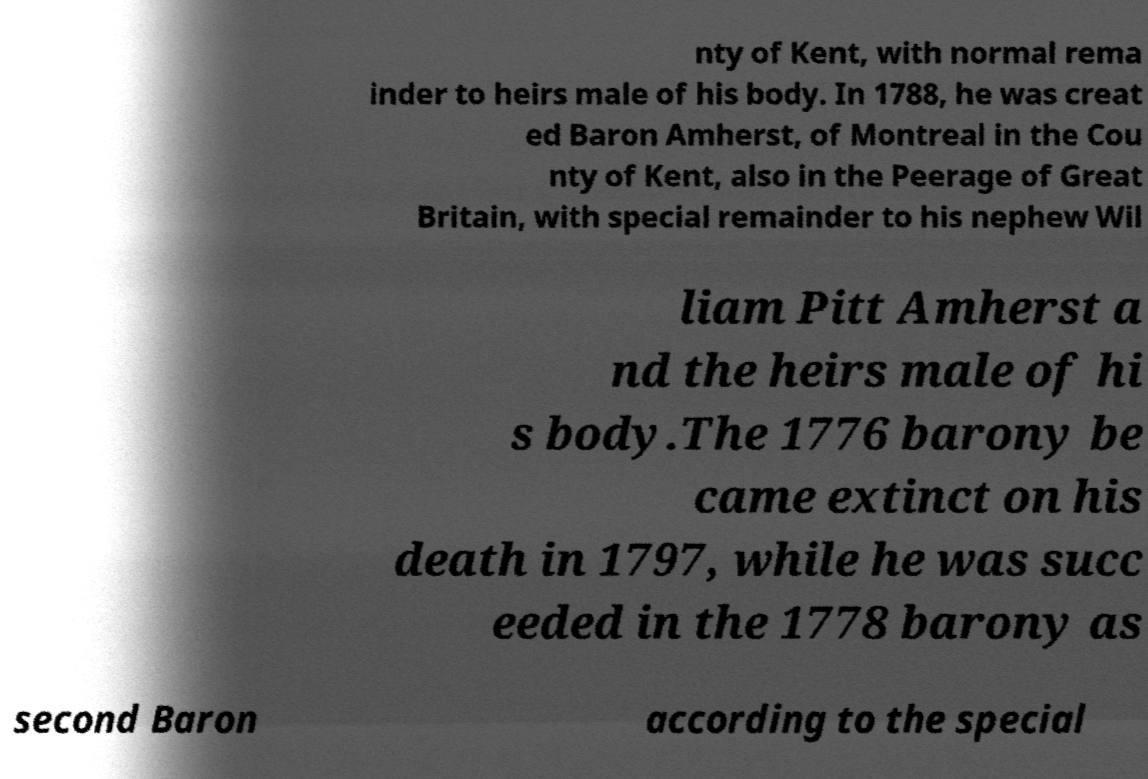For documentation purposes, I need the text within this image transcribed. Could you provide that? nty of Kent, with normal rema inder to heirs male of his body. In 1788, he was creat ed Baron Amherst, of Montreal in the Cou nty of Kent, also in the Peerage of Great Britain, with special remainder to his nephew Wil liam Pitt Amherst a nd the heirs male of hi s body.The 1776 barony be came extinct on his death in 1797, while he was succ eeded in the 1778 barony as second Baron according to the special 